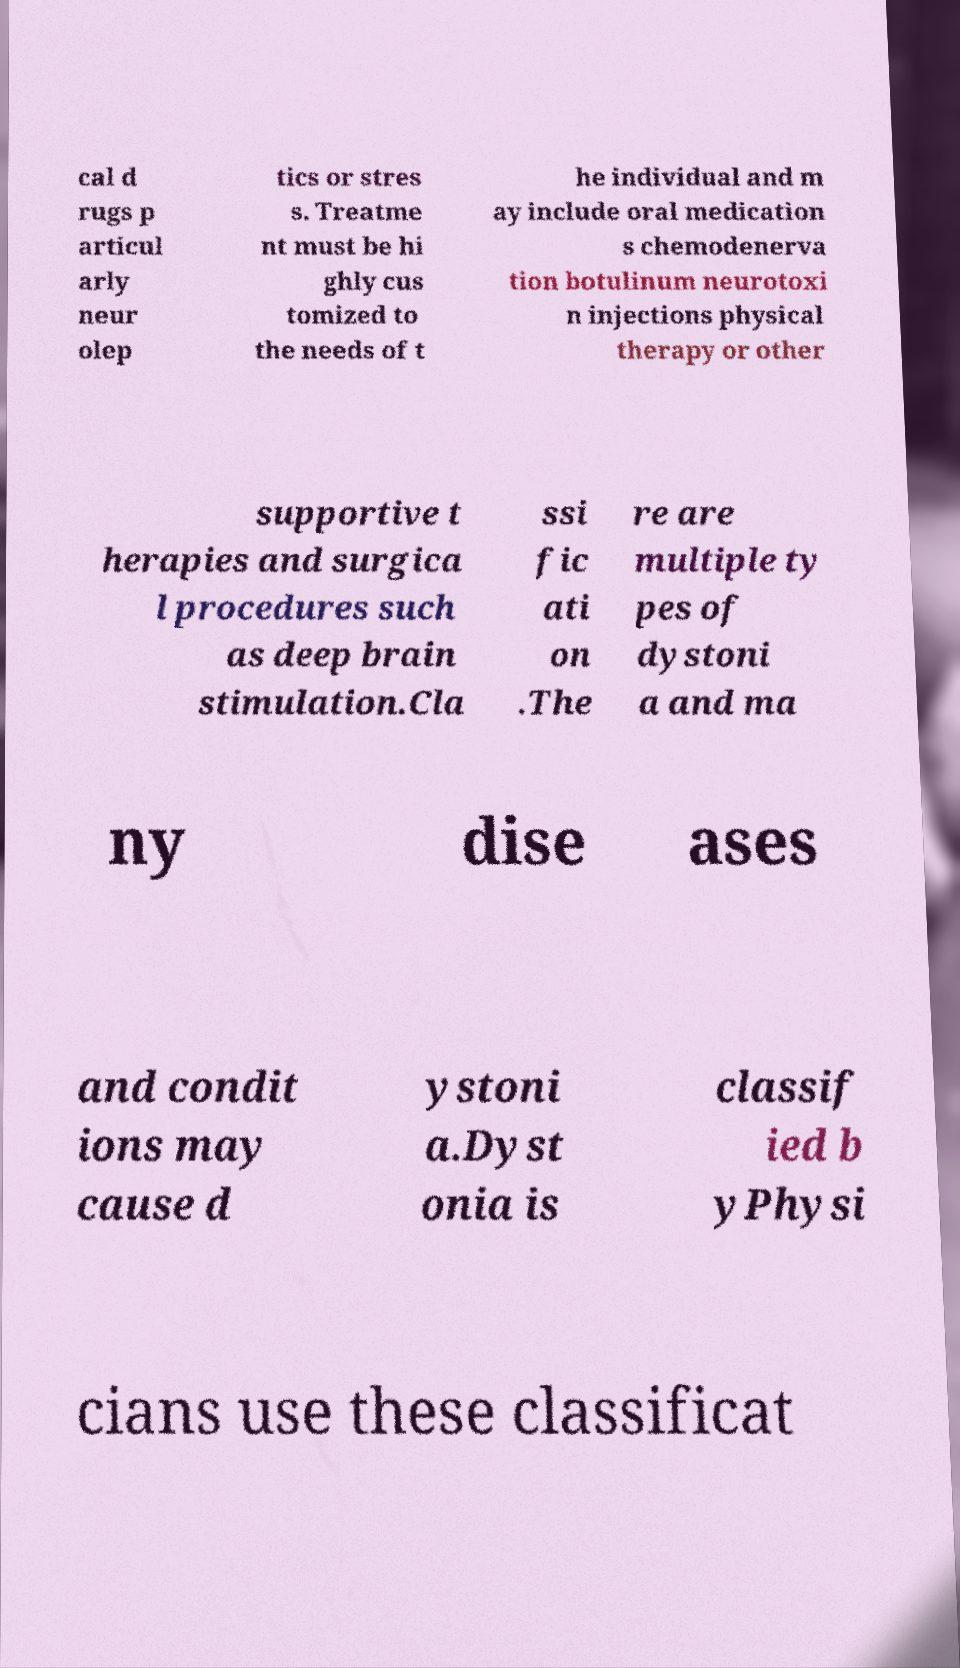Could you extract and type out the text from this image? cal d rugs p articul arly neur olep tics or stres s. Treatme nt must be hi ghly cus tomized to the needs of t he individual and m ay include oral medication s chemodenerva tion botulinum neurotoxi n injections physical therapy or other supportive t herapies and surgica l procedures such as deep brain stimulation.Cla ssi fic ati on .The re are multiple ty pes of dystoni a and ma ny dise ases and condit ions may cause d ystoni a.Dyst onia is classif ied b yPhysi cians use these classificat 